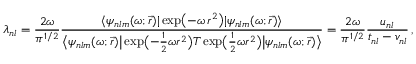Convert formula to latex. <formula><loc_0><loc_0><loc_500><loc_500>\lambda _ { n l } = \frac { 2 \omega } { \pi ^ { 1 / 2 } } \frac { \langle \psi _ { n l m } ( \omega ; \vec { r } ) | \exp \left ( - \omega \, r ^ { 2 } \right ) | \psi _ { n l m } ( \omega ; \vec { r } ) \rangle } { \left \langle \psi _ { n l m } ( \omega ; \vec { r } ) \left | \exp \left ( - \frac { 1 } { 2 } \omega r ^ { 2 } \right ) T \exp \left ( \frac { 1 } { 2 } \omega r ^ { 2 } \right ) \right | \psi _ { n l m } ( \omega ; \vec { r } ) \right \rangle } = \frac { 2 \omega } { \pi ^ { 1 / 2 } } \frac { u _ { n l } } { t _ { n l } - v _ { n l } } \, ,</formula> 